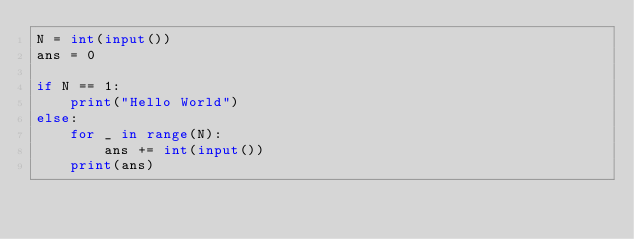<code> <loc_0><loc_0><loc_500><loc_500><_Python_>N = int(input())
ans = 0

if N == 1:
    print("Hello World")
else:
    for _ in range(N):
        ans += int(input())
    print(ans)
</code> 